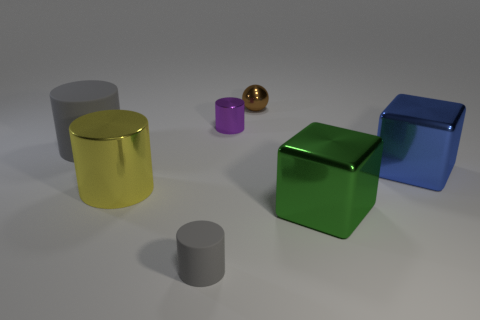The matte object that is the same size as the purple shiny object is what shape?
Ensure brevity in your answer.  Cylinder. What number of objects are gray cylinders that are to the left of the small gray cylinder or big matte things?
Make the answer very short. 1. Does the small metallic sphere have the same color as the tiny metal cylinder?
Your answer should be very brief. No. There is a gray cylinder that is to the left of the small gray thing; what size is it?
Offer a very short reply. Large. Are there any yellow shiny blocks of the same size as the brown object?
Your answer should be compact. No. Does the shiny cube that is to the left of the blue object have the same size as the large matte cylinder?
Your answer should be compact. Yes. The brown metallic sphere is what size?
Make the answer very short. Small. The metal cylinder that is behind the gray object to the left of the large metal thing that is left of the brown object is what color?
Ensure brevity in your answer.  Purple. There is a big cube that is behind the yellow object; does it have the same color as the small metal cylinder?
Provide a succinct answer. No. What number of objects are in front of the big yellow object and right of the brown object?
Offer a terse response. 1. 